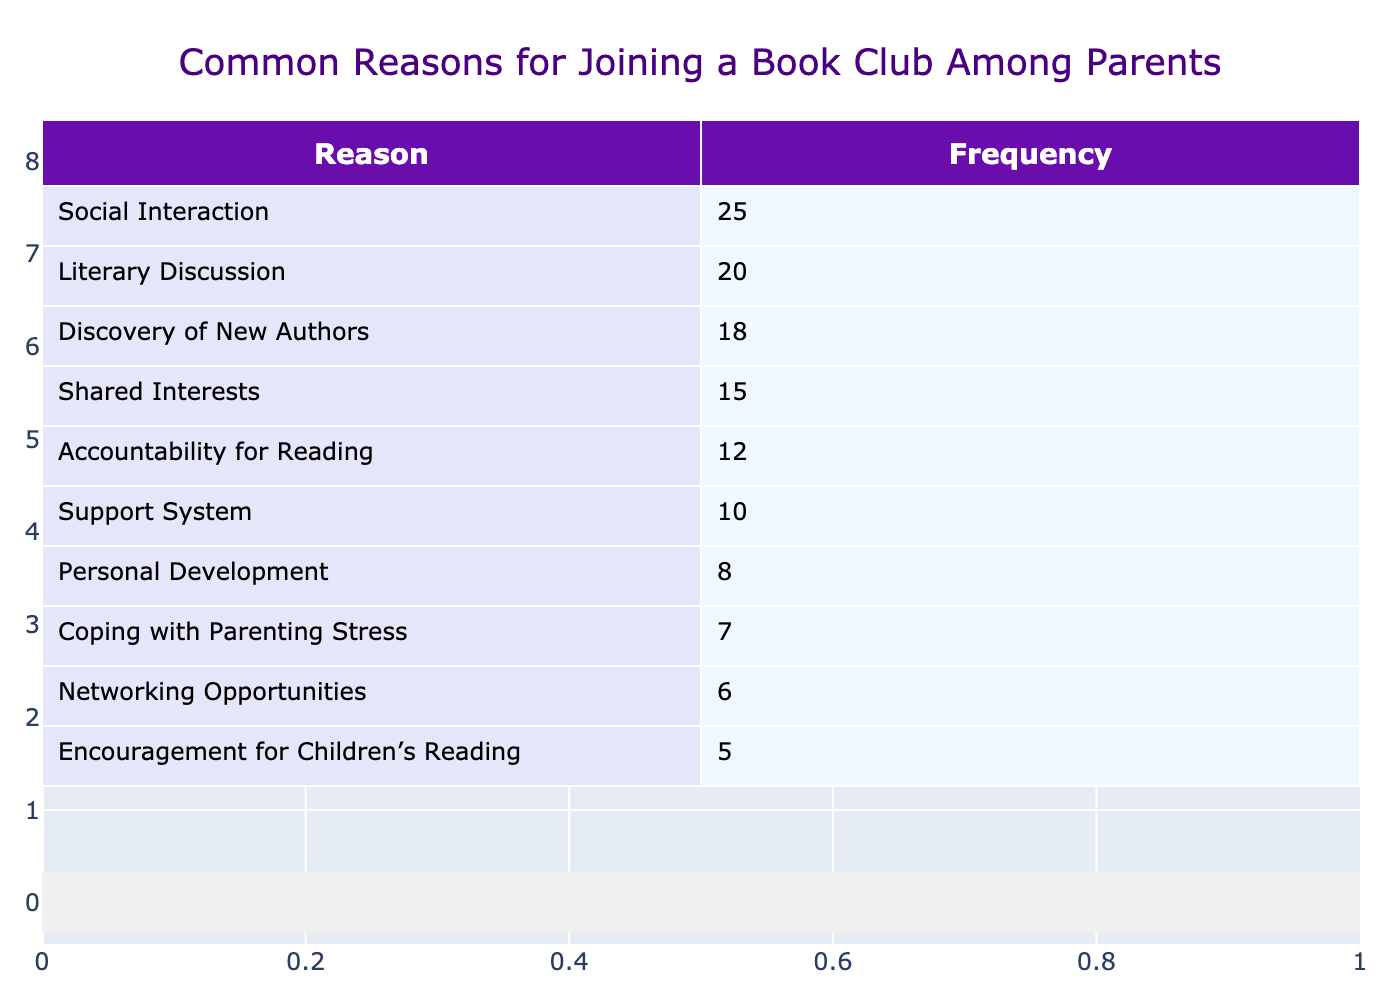What is the most common reason for joining a book club among parents? The table shows the frequency for each reason, and the highest value is for "Social Interaction," which has a frequency of 25.
Answer: Social Interaction How many parents expressed a desire for “Coping with Parenting Stress”? "Coping with Parenting Stress" has a frequency of 7, as listed in the table.
Answer: 7 What is the total frequency for the reasons related to social aspects? The reasons related to social aspects are "Social Interaction" (25) and "Support System" (10). Adding these gives 25 + 10 = 35.
Answer: 35 Is "Encouragement for Children's Reading" more common than "Networking Opportunities"? "Encouragement for Children's Reading" has a frequency of 5, while "Networking Opportunities" has a frequency of 6. Since 5 is less than 6, the statement is false.
Answer: No What is the frequency difference between "Discovery of New Authors" and "Accountability for Reading"? "Discovery of New Authors" has a frequency of 18, and "Accountability for Reading" has 12. The difference is 18 - 12 = 6.
Answer: 6 What is the average frequency of the reasons listed in the table? To find the average, sum all frequencies: 25 + 20 + 15 + 10 + 18 + 12 + 8 + 7 + 5 + 6 = 126. There are 10 reasons, so the average is 126 / 10 = 12.6.
Answer: 12.6 How many more parents are interested in "Literary Discussion" compared to "Personal Development"? "Literary Discussion" has a frequency of 20 and "Personal Development" has 8. The difference is 20 - 8 = 12, which shows more interest in Literary Discussion.
Answer: 12 Which two reasons have the lowest frequencies? The two reasons with the lowest frequencies are "Coping with Parenting Stress" (7) and "Encouragement for Children's Reading" (5) as seen in the table.
Answer: Coping with Parenting Stress and Encouragement for Children's Reading What is the total frequency for “Shared Interests” and “Discovery of New Authors”? The frequency for "Shared Interests" is 15 and for "Discovery of New Authors" is 18. Adding these gives 15 + 18 = 33.
Answer: 33 